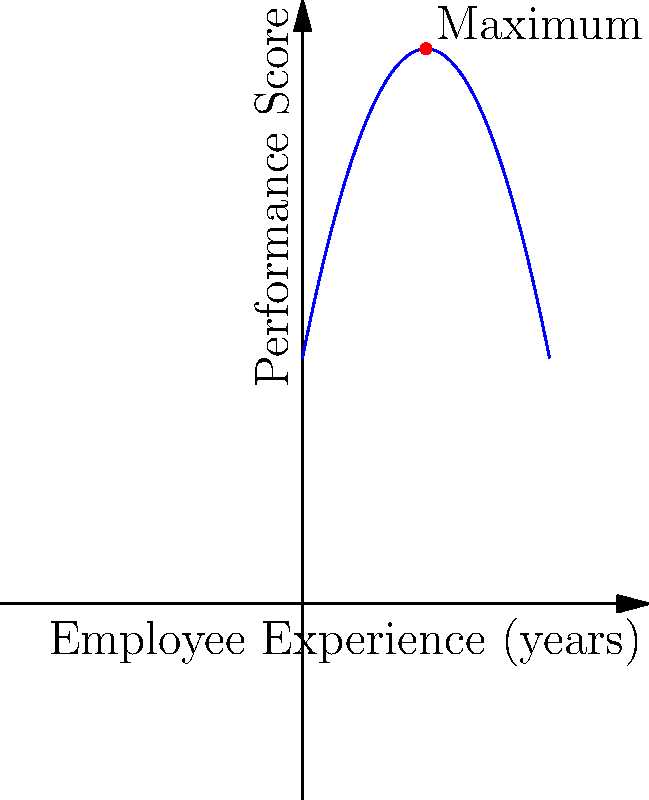A data analyst has provided you with a function representing employee performance based on years of experience: $f(x) = -0.5x^2 + 5x + 10$, where $x$ is the years of experience and $f(x)$ is the performance score. Find the number of years of experience at which employee performance is maximized. To find the maximum point of a parabolic function, we need to follow these steps:

1) The general form of a quadratic function is $f(x) = ax^2 + bx + c$. In this case:
   $a = -0.5$, $b = 5$, and $c = 10$

2) For a parabola, the x-coordinate of the vertex (which represents the maximum point for a downward-facing parabola) is given by the formula: $x = -\frac{b}{2a}$

3) Substituting our values:
   $x = -\frac{5}{2(-0.5)} = -\frac{5}{-1} = 5$

4) Therefore, the maximum point occurs when $x = 5$, which represents 5 years of experience.

5) To verify, we can calculate the y-coordinate by plugging x = 5 into the original function:
   $f(5) = -0.5(5^2) + 5(5) + 10 = -12.5 + 25 + 10 = 22.5$

Thus, the maximum point is at (5, 22.5), indicating that employee performance is maximized at 5 years of experience with a performance score of 22.5.
Answer: 5 years 